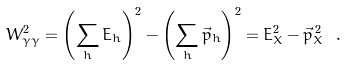<formula> <loc_0><loc_0><loc_500><loc_500>W _ { \gamma \gamma } ^ { 2 } = \left ( \sum _ { h } E _ { h } \right ) ^ { 2 } - \left ( \sum _ { h } \vec { p } _ { h } \right ) ^ { 2 } = E ^ { 2 } _ { X } - \vec { p } ^ { \, 2 } _ { X } \ .</formula> 